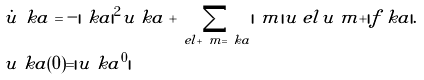<formula> <loc_0><loc_0><loc_500><loc_500>& \dot { \tilde { u } } _ { \ } k a = - | \ k a | ^ { 2 } \tilde { u } _ { \ } k a + \sum _ { \ e l + \ m = \ k a } | \ m | \tilde { u } _ { \ } e l \tilde { u } _ { \ } m + | f _ { \ } k a | . \\ & \tilde { u } _ { \ } k a ( 0 ) = | u _ { \ } k a ^ { 0 } |</formula> 